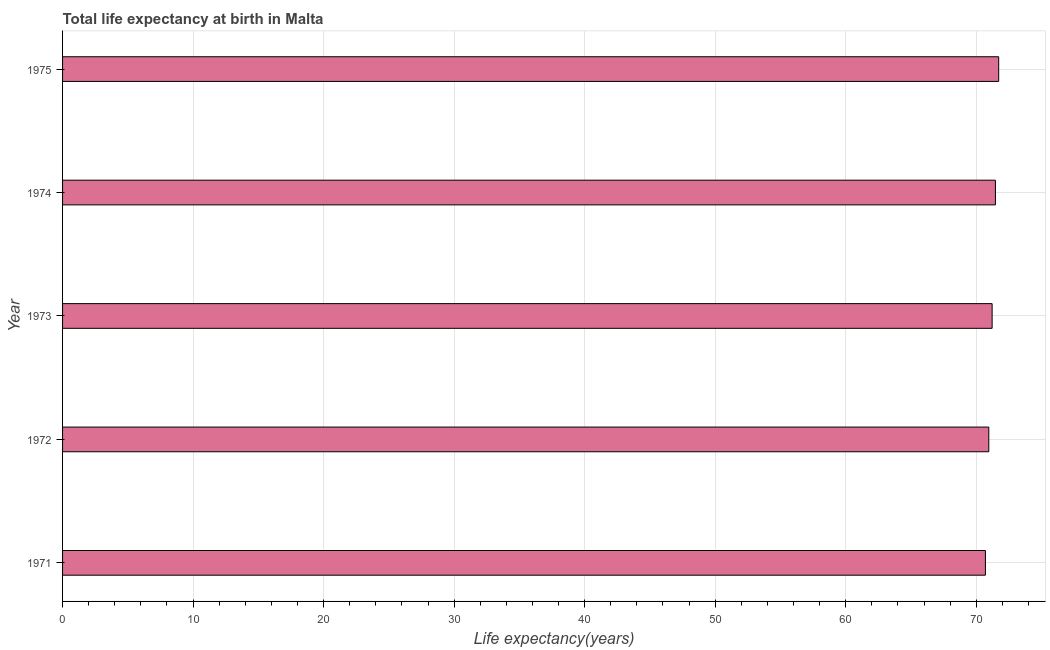Does the graph contain any zero values?
Provide a succinct answer. No. What is the title of the graph?
Your response must be concise. Total life expectancy at birth in Malta. What is the label or title of the X-axis?
Ensure brevity in your answer.  Life expectancy(years). What is the life expectancy at birth in 1972?
Your answer should be very brief. 70.96. Across all years, what is the maximum life expectancy at birth?
Provide a succinct answer. 71.72. Across all years, what is the minimum life expectancy at birth?
Provide a succinct answer. 70.7. In which year was the life expectancy at birth maximum?
Your answer should be compact. 1975. In which year was the life expectancy at birth minimum?
Ensure brevity in your answer.  1971. What is the sum of the life expectancy at birth?
Your answer should be very brief. 356.08. What is the difference between the life expectancy at birth in 1971 and 1972?
Your answer should be very brief. -0.26. What is the average life expectancy at birth per year?
Offer a terse response. 71.22. What is the median life expectancy at birth?
Provide a short and direct response. 71.22. Do a majority of the years between 1974 and 1972 (inclusive) have life expectancy at birth greater than 60 years?
Your answer should be very brief. Yes. What is the ratio of the life expectancy at birth in 1971 to that in 1973?
Give a very brief answer. 0.99. Is the life expectancy at birth in 1971 less than that in 1973?
Give a very brief answer. Yes. Is the difference between the life expectancy at birth in 1972 and 1973 greater than the difference between any two years?
Give a very brief answer. No. What is the difference between the highest and the second highest life expectancy at birth?
Offer a terse response. 0.25. Is the sum of the life expectancy at birth in 1972 and 1973 greater than the maximum life expectancy at birth across all years?
Make the answer very short. Yes. What is the difference between the highest and the lowest life expectancy at birth?
Provide a short and direct response. 1.02. In how many years, is the life expectancy at birth greater than the average life expectancy at birth taken over all years?
Provide a succinct answer. 3. What is the difference between two consecutive major ticks on the X-axis?
Your answer should be very brief. 10. What is the Life expectancy(years) in 1971?
Keep it short and to the point. 70.7. What is the Life expectancy(years) of 1972?
Provide a succinct answer. 70.96. What is the Life expectancy(years) of 1973?
Give a very brief answer. 71.22. What is the Life expectancy(years) in 1974?
Your answer should be very brief. 71.47. What is the Life expectancy(years) in 1975?
Your answer should be very brief. 71.72. What is the difference between the Life expectancy(years) in 1971 and 1972?
Provide a succinct answer. -0.26. What is the difference between the Life expectancy(years) in 1971 and 1973?
Ensure brevity in your answer.  -0.51. What is the difference between the Life expectancy(years) in 1971 and 1974?
Make the answer very short. -0.77. What is the difference between the Life expectancy(years) in 1971 and 1975?
Your response must be concise. -1.02. What is the difference between the Life expectancy(years) in 1972 and 1973?
Offer a very short reply. -0.26. What is the difference between the Life expectancy(years) in 1972 and 1974?
Give a very brief answer. -0.51. What is the difference between the Life expectancy(years) in 1972 and 1975?
Make the answer very short. -0.76. What is the difference between the Life expectancy(years) in 1973 and 1974?
Your response must be concise. -0.25. What is the difference between the Life expectancy(years) in 1973 and 1975?
Your answer should be compact. -0.5. What is the difference between the Life expectancy(years) in 1974 and 1975?
Give a very brief answer. -0.25. What is the ratio of the Life expectancy(years) in 1971 to that in 1973?
Keep it short and to the point. 0.99. What is the ratio of the Life expectancy(years) in 1971 to that in 1974?
Provide a succinct answer. 0.99. What is the ratio of the Life expectancy(years) in 1972 to that in 1973?
Provide a short and direct response. 1. What is the ratio of the Life expectancy(years) in 1972 to that in 1974?
Offer a terse response. 0.99. What is the ratio of the Life expectancy(years) in 1973 to that in 1974?
Give a very brief answer. 1. What is the ratio of the Life expectancy(years) in 1973 to that in 1975?
Keep it short and to the point. 0.99. What is the ratio of the Life expectancy(years) in 1974 to that in 1975?
Provide a succinct answer. 1. 